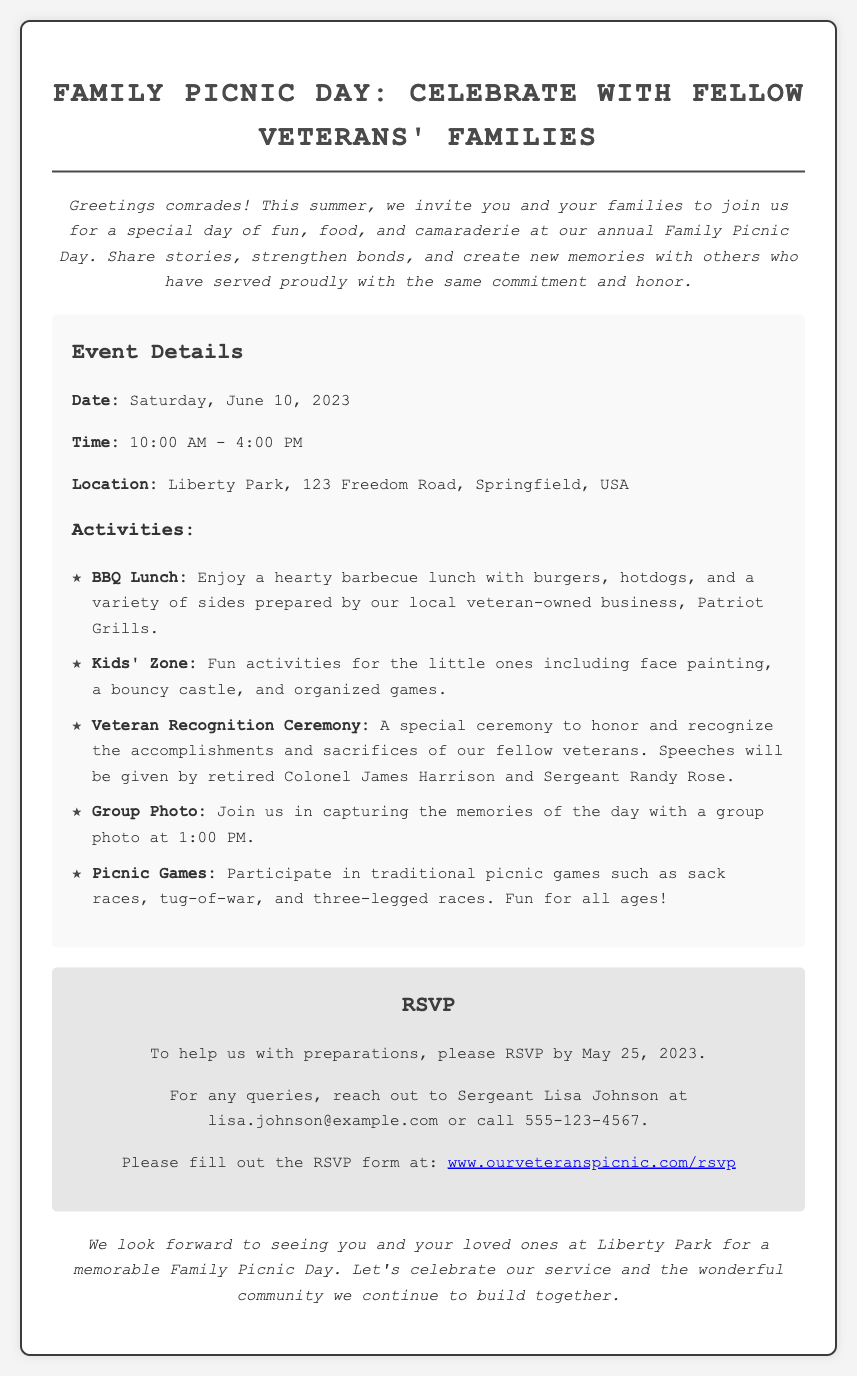What is the event date? The event date is explicitly provided in the document, which states that it takes place on June 10, 2023.
Answer: June 10, 2023 What time does the event start? The document clearly lists the starting time of the event as 10:00 AM.
Answer: 10:00 AM Who should be contacted for queries? The document mentions Sergeant Lisa Johnson as the contact person for any queries regarding the event.
Answer: Sergeant Lisa Johnson Where is the event location? The location of the event is given in the document as Liberty Park, 123 Freedom Road, Springfield, USA.
Answer: Liberty Park, 123 Freedom Road, Springfield, USA What activities are included in the picnic? The document lists multiple activities, such as BBQ Lunch, Kids' Zone, Veteran Recognition Ceremony, Group Photo, and Picnic Games.
Answer: BBQ Lunch, Kids' Zone, Veteran Recognition Ceremony, Group Photo, Picnic Games What is the RSVP deadline? The RSVP deadline to help with preparations is explicitly stated in the document as May 25, 2023.
Answer: May 25, 2023 How can I RSVP? The document specifies that one can RSVP by filling out a form available at a provided link, which is www.ourveteranspicnic.com/rsvp.
Answer: www.ourveteranspicnic.com/rsvp Who is giving speeches at the Veteran Recognition Ceremony? The document mentions that speeches will be given by retired Colonel James Harrison and Sergeant Randy Rose during the ceremony.
Answer: retired Colonel James Harrison and Sergeant Randy Rose What type of food will be served? The document describes that the food served will include burgers, hotdogs, and a variety of sides prepared by a local veteran-owned business.
Answer: BBQ Lunch with burgers and hotdogs 